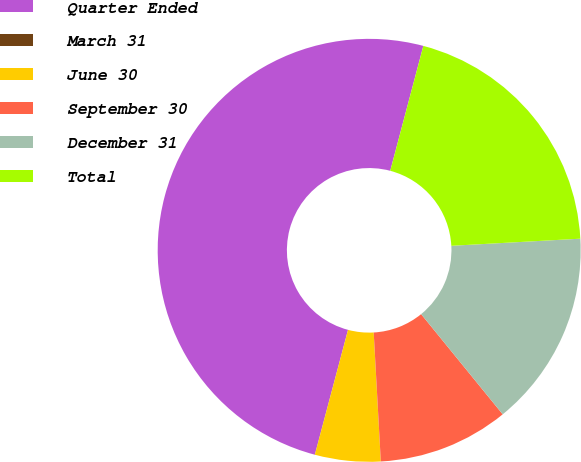Convert chart to OTSL. <chart><loc_0><loc_0><loc_500><loc_500><pie_chart><fcel>Quarter Ended<fcel>March 31<fcel>June 30<fcel>September 30<fcel>December 31<fcel>Total<nl><fcel>49.98%<fcel>0.01%<fcel>5.01%<fcel>10.0%<fcel>15.0%<fcel>20.0%<nl></chart> 